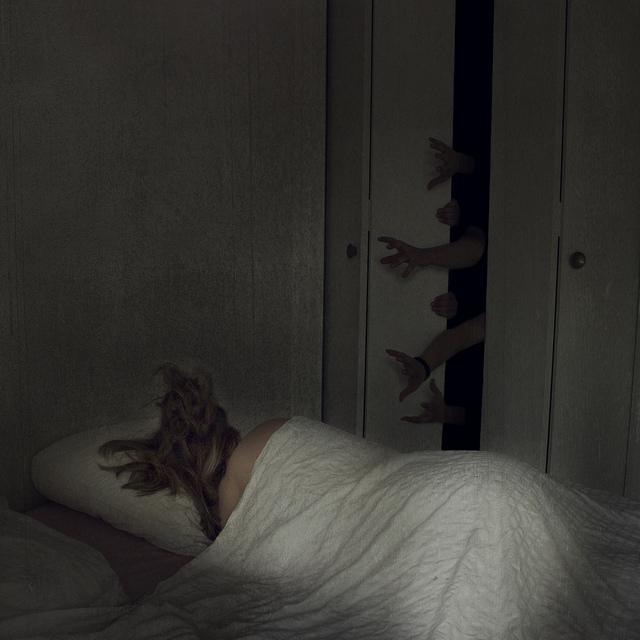How many people are there?
Give a very brief answer. 3. 